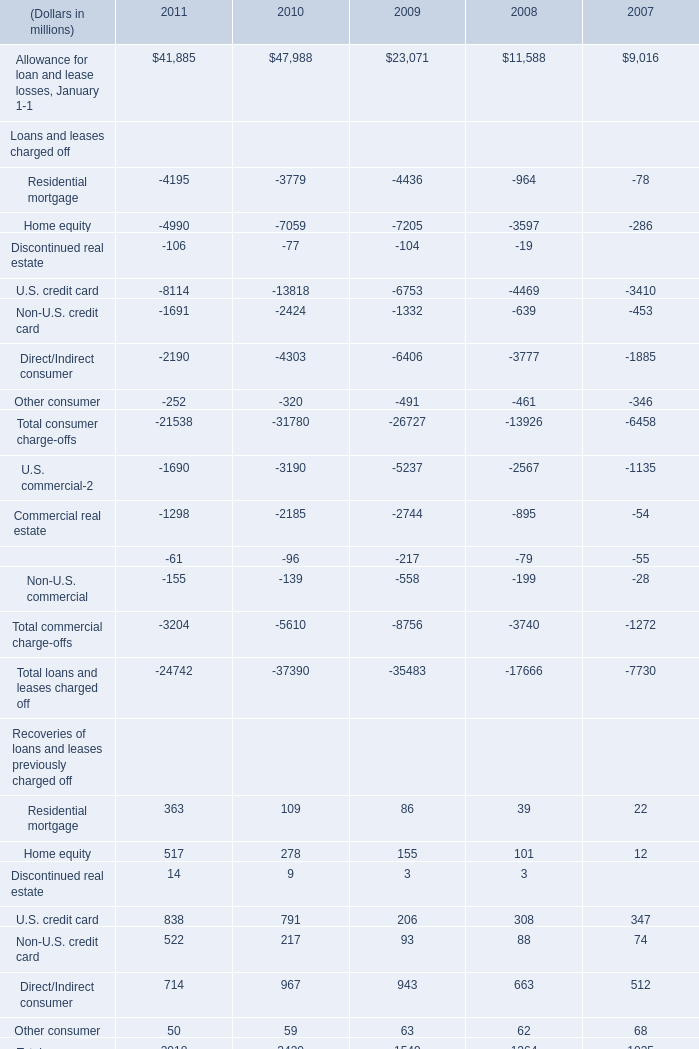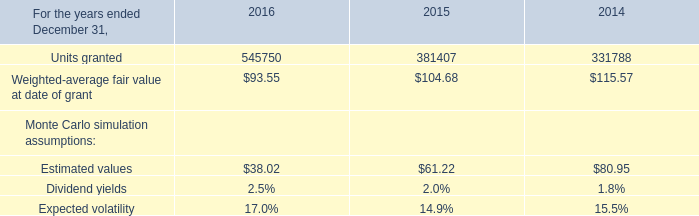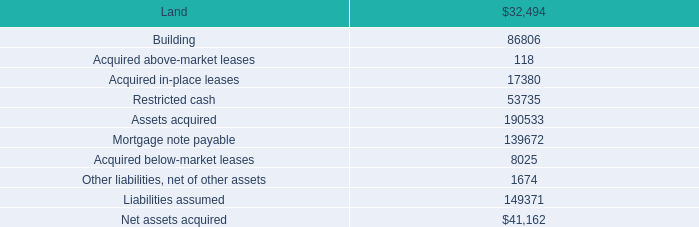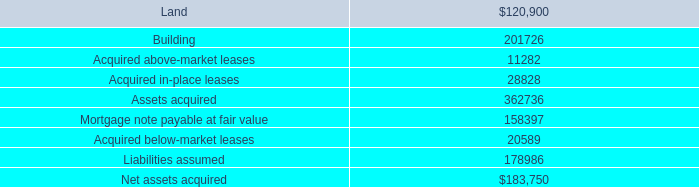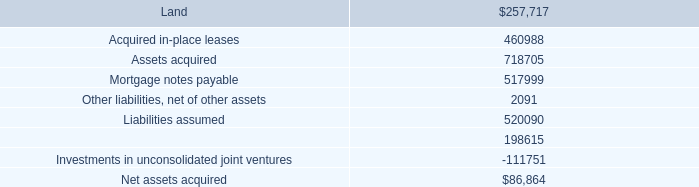What's the sum of U.S. commercial Loans and leases charged off of 2010, and Mortgage note payable at fair value ? 
Computations: (3190.0 + 158397.0)
Answer: 161587.0. 